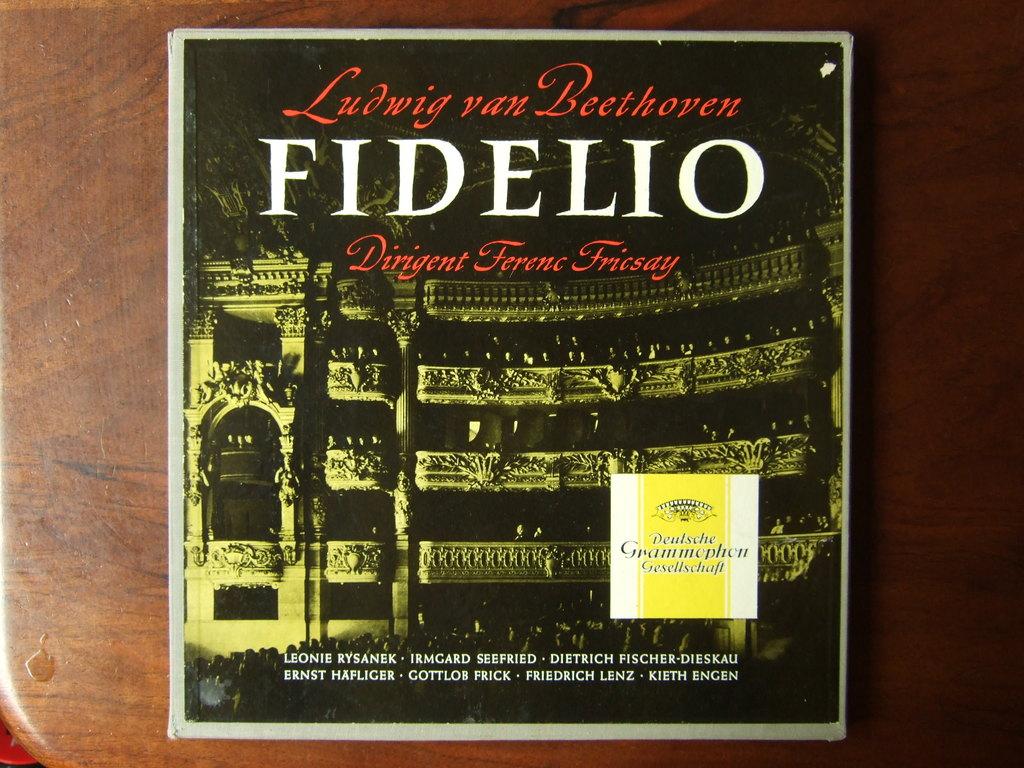Who wrote this?
Offer a terse response. Ludwig van beethoven. 